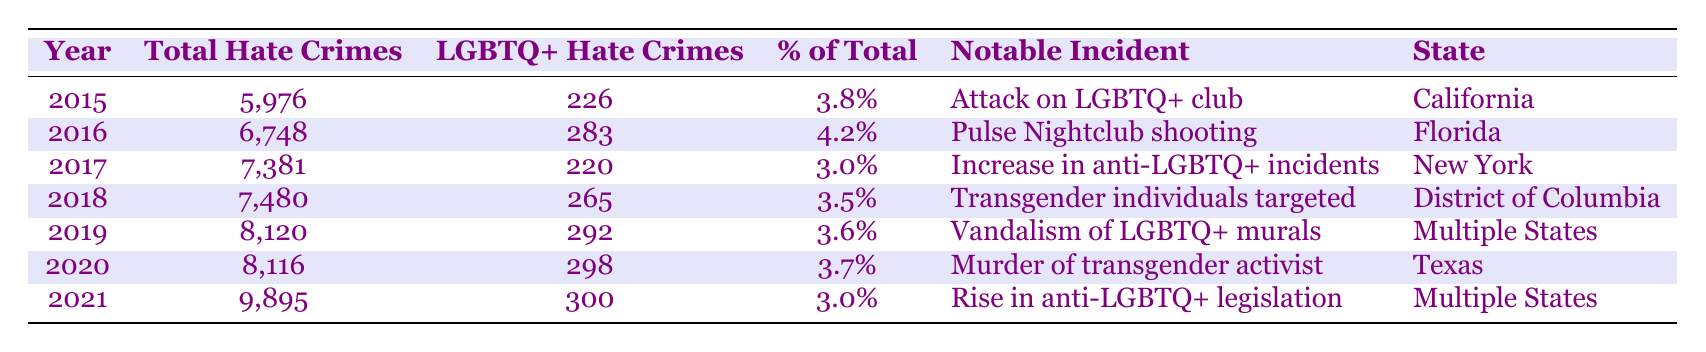What was the total number of LGBTQ+ hate crimes reported in 2016? In the year 2016, the table shows that there were 283 LGBTQ+ hate crimes reported, which can be found in the corresponding row under the "LGBTQ+ Hate Crimes" column for that year.
Answer: 283 What notable incident occurred related to LGBTQ+ hate crimes in 2017? The table indicates that in 2017, the notable incident was an increase in anti-LGBTQ+ incidents after the election, which is listed under the "Notable Incident" column for that year.
Answer: Increase in anti-LGBTQ+ incidents after election What was the percentage of total hate crimes that were LGBTQ+ in 2018? The percentage of total hate crimes that were LGBTQ+ in 2018 is 3.5%, as noted in the table under the "% of Total" column for that year.
Answer: 3.5% How many total hate crimes were reported from 2015 to 2021? To find the total hate crimes from 2015 to 2021, you sum the total hate crimes for each year: 5976 + 6748 + 7381 + 7480 + 8120 + 8116 + 9895 =  49,416. Thus, the total hate crimes reported is 49,416.
Answer: 49,416 Did the percentage of LGBTQ+ hate crimes increase from 2019 to 2021? In 2019, the percentage was 3.6%, and in 2021 it was 3.0%, indicating a decrease from 2019 to 2021. Therefore, the statement is false.
Answer: No What is the difference in the number of LGBTQ+ hate crimes reported between 2020 and 2021? For 2020, the number of LGBTQ+ hate crimes was 298, and for 2021, it was 300. The difference is calculated as 300 - 298 = 2. Thus, there were 2 more LGBTQ+ hate crimes reported in 2021 compared to 2020.
Answer: 2 What state reported a notable incident related to the murder of a prominent transgender activist? According to the table, the state where the notable incident of the murder of a prominent transgender activist occurred in 2020 is Texas, as indicated in the "State" column for that year.
Answer: Texas What is the average number of LGBTQ+ hate crimes reported from 2015 to 2021? To find the average, sum the LGBTQ+ hate crimes over the seven years: 226 + 283 + 220 + 265 + 292 + 298 + 300 = 1884. Since there are 7 years, divide the total by 7: 1884 / 7 = approximately 269.14. Rounding down gives an average of about 269.
Answer: 269 Was the number of total hate crimes higher in 2021 than in 2016? In 2021, the total reported hate crimes were 9895, while in 2016 they were 6748. Since 9895 is greater than 6748, the statement is true.
Answer: Yes 